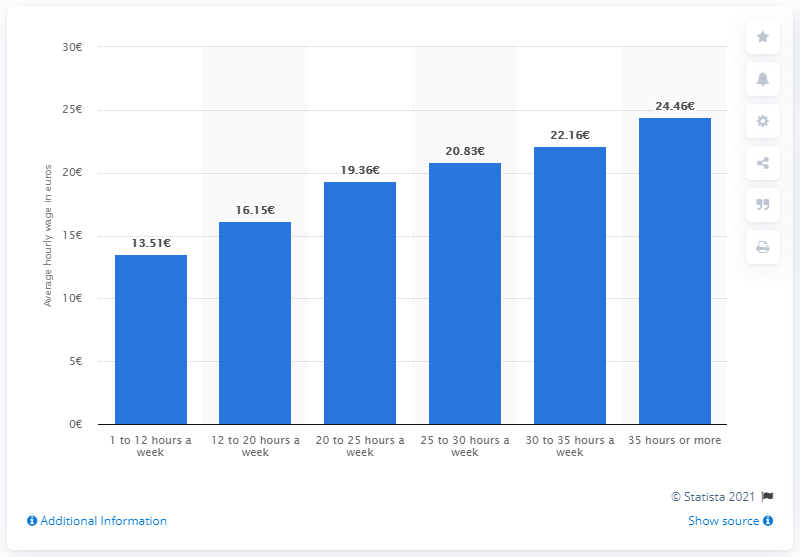Highlight a few significant elements in this photo. In the Netherlands, the maximum hourly wage is 35 hours or more. 